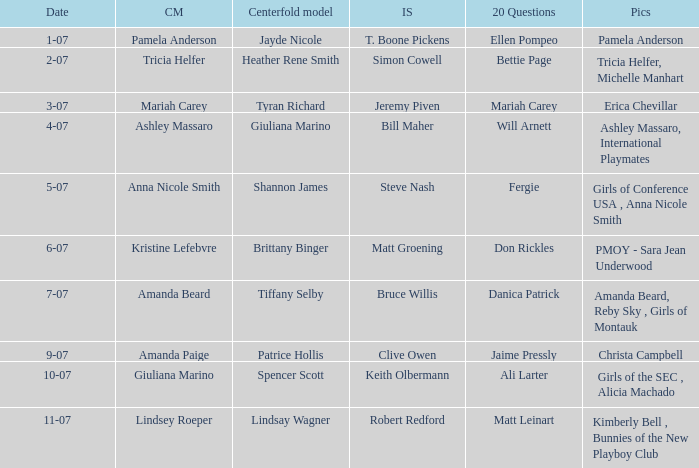Who was the centerfold model in the issue where Fergie answered the "20 questions"? Shannon James. 